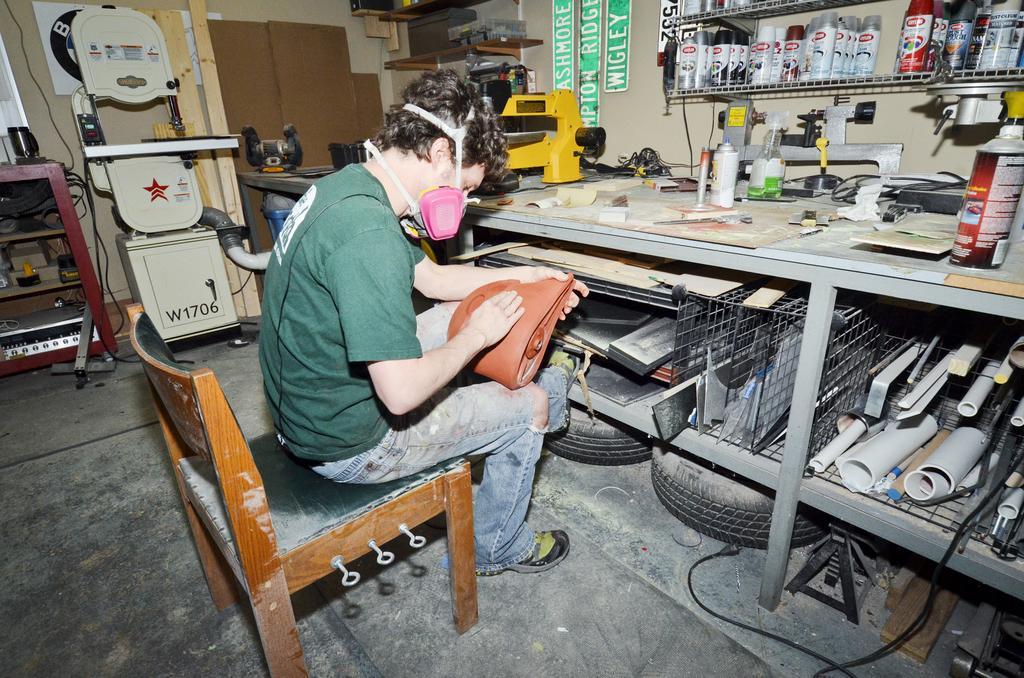Please provide a concise description of this image. In this picture I can see there is a man sitting here and wearing a mask and he is holding a object, there is a table in front of him. On the floor I can see there is Tyre. 